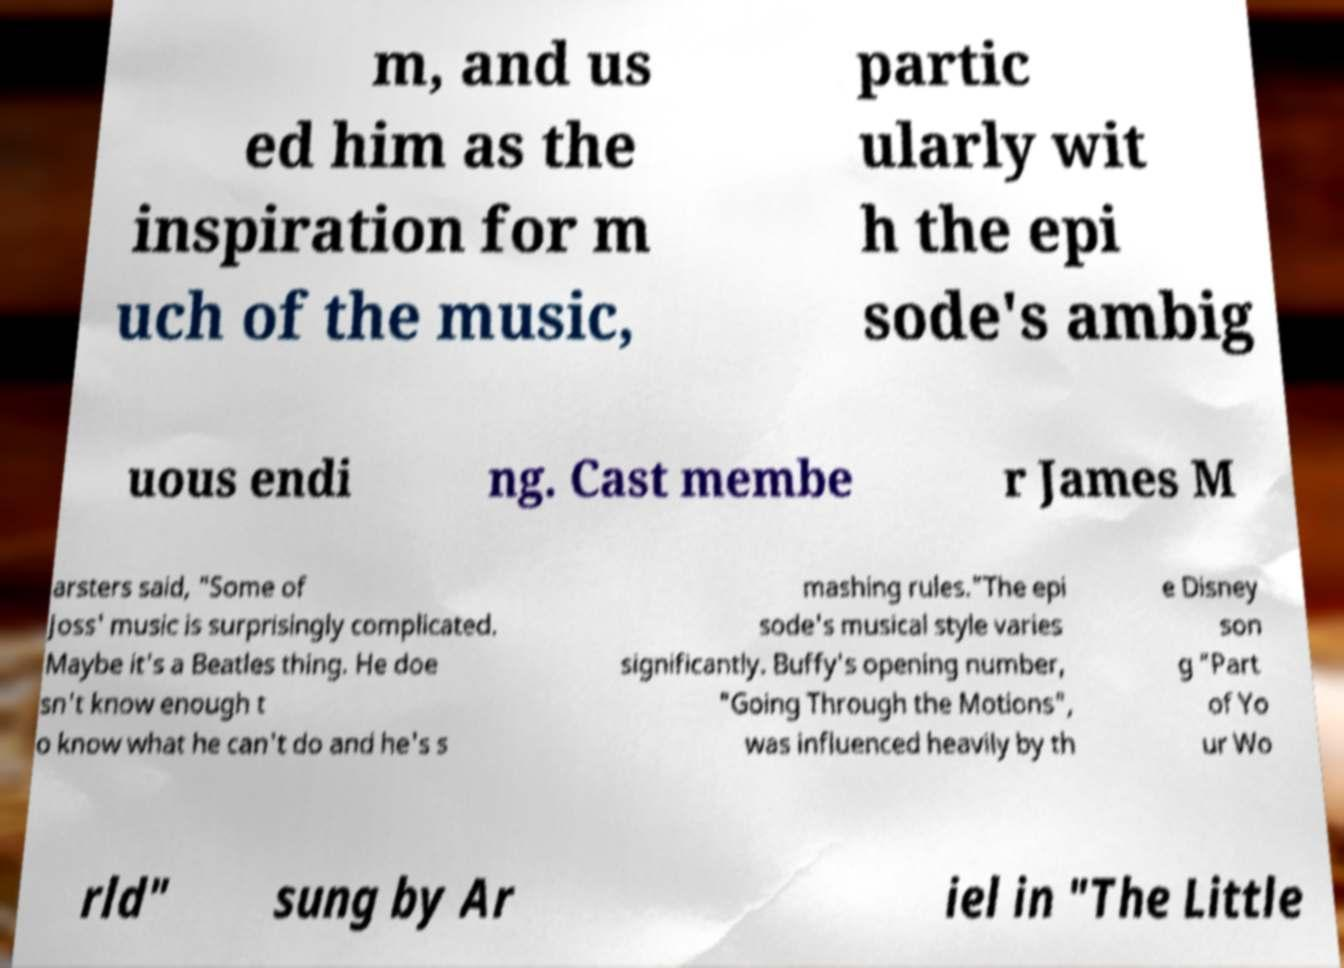Can you read and provide the text displayed in the image?This photo seems to have some interesting text. Can you extract and type it out for me? m, and us ed him as the inspiration for m uch of the music, partic ularly wit h the epi sode's ambig uous endi ng. Cast membe r James M arsters said, "Some of Joss' music is surprisingly complicated. Maybe it's a Beatles thing. He doe sn't know enough t o know what he can't do and he's s mashing rules."The epi sode's musical style varies significantly. Buffy's opening number, "Going Through the Motions", was influenced heavily by th e Disney son g "Part of Yo ur Wo rld" sung by Ar iel in "The Little 